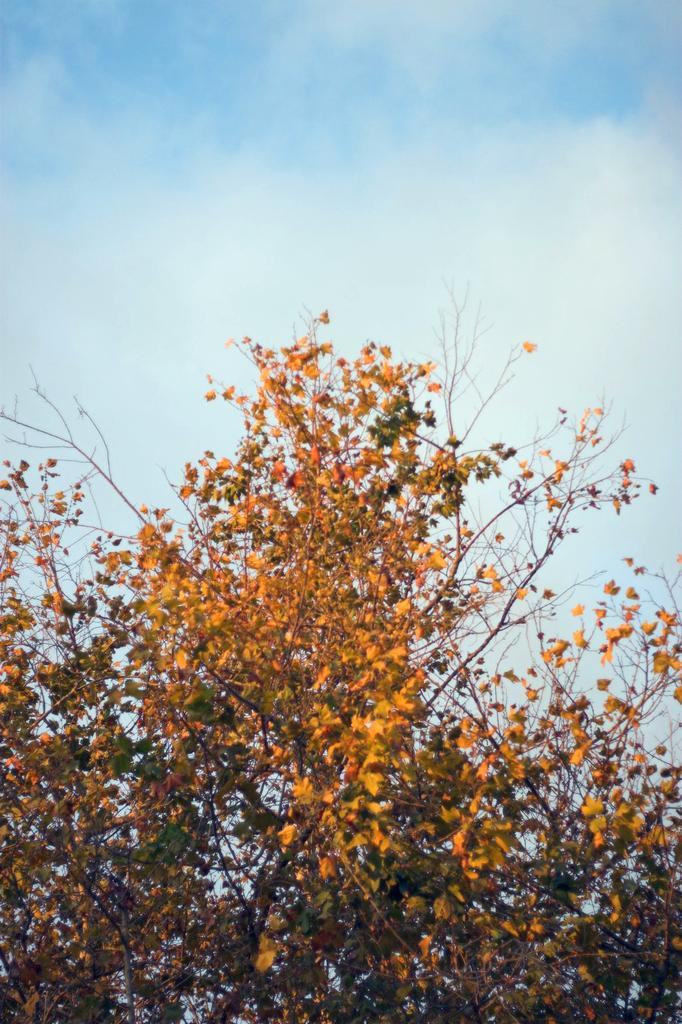How would you summarize this image in a sentence or two? In this image we can see branches of trees with leaves. In the background there is sky with clouds. 